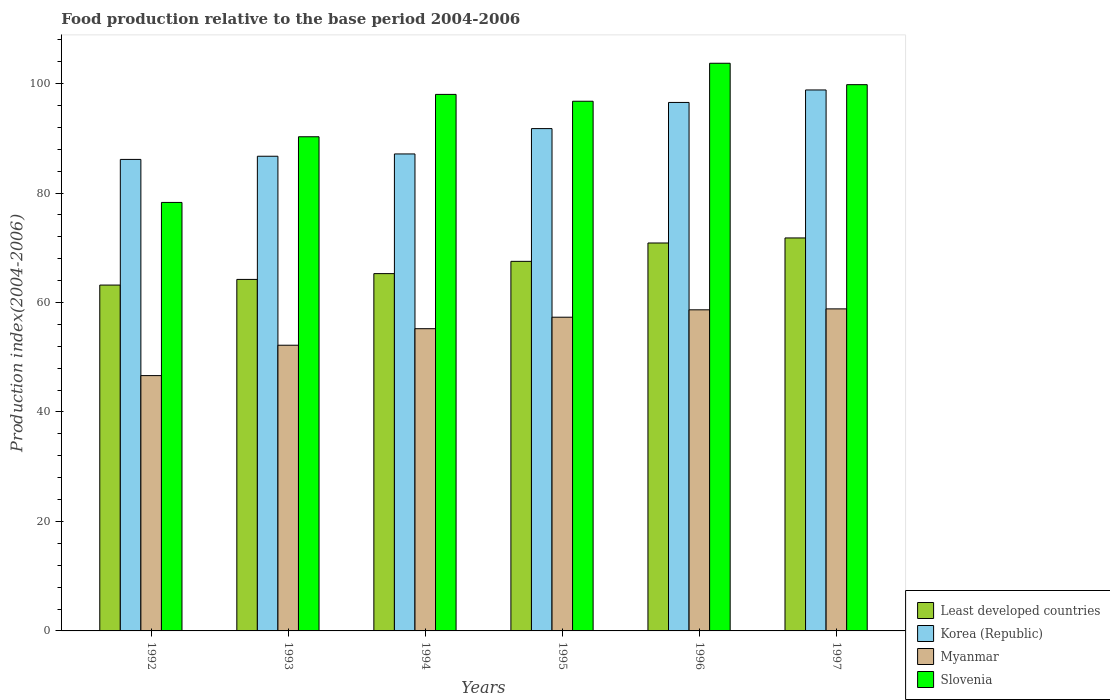How many different coloured bars are there?
Provide a short and direct response. 4. How many groups of bars are there?
Give a very brief answer. 6. How many bars are there on the 6th tick from the left?
Offer a terse response. 4. In how many cases, is the number of bars for a given year not equal to the number of legend labels?
Make the answer very short. 0. What is the food production index in Korea (Republic) in 1997?
Make the answer very short. 98.84. Across all years, what is the maximum food production index in Least developed countries?
Ensure brevity in your answer.  71.8. Across all years, what is the minimum food production index in Myanmar?
Your response must be concise. 46.65. What is the total food production index in Least developed countries in the graph?
Offer a very short reply. 402.91. What is the difference between the food production index in Slovenia in 1994 and that in 1997?
Provide a short and direct response. -1.78. What is the difference between the food production index in Korea (Republic) in 1992 and the food production index in Myanmar in 1995?
Make the answer very short. 28.83. What is the average food production index in Korea (Republic) per year?
Offer a very short reply. 91.2. In the year 1993, what is the difference between the food production index in Slovenia and food production index in Myanmar?
Ensure brevity in your answer.  38.09. In how many years, is the food production index in Slovenia greater than 40?
Provide a short and direct response. 6. What is the ratio of the food production index in Slovenia in 1993 to that in 1995?
Offer a terse response. 0.93. Is the food production index in Myanmar in 1992 less than that in 1994?
Keep it short and to the point. Yes. What is the difference between the highest and the second highest food production index in Slovenia?
Ensure brevity in your answer.  3.91. What is the difference between the highest and the lowest food production index in Korea (Republic)?
Provide a short and direct response. 12.69. In how many years, is the food production index in Myanmar greater than the average food production index in Myanmar taken over all years?
Give a very brief answer. 4. Is the sum of the food production index in Least developed countries in 1992 and 1997 greater than the maximum food production index in Myanmar across all years?
Ensure brevity in your answer.  Yes. What does the 3rd bar from the left in 1997 represents?
Offer a terse response. Myanmar. What does the 2nd bar from the right in 1992 represents?
Your answer should be compact. Myanmar. Is it the case that in every year, the sum of the food production index in Myanmar and food production index in Korea (Republic) is greater than the food production index in Slovenia?
Offer a terse response. Yes. How many years are there in the graph?
Your answer should be compact. 6. Where does the legend appear in the graph?
Offer a terse response. Bottom right. How many legend labels are there?
Keep it short and to the point. 4. How are the legend labels stacked?
Your response must be concise. Vertical. What is the title of the graph?
Your response must be concise. Food production relative to the base period 2004-2006. Does "Cayman Islands" appear as one of the legend labels in the graph?
Your answer should be compact. No. What is the label or title of the X-axis?
Your response must be concise. Years. What is the label or title of the Y-axis?
Offer a very short reply. Production index(2004-2006). What is the Production index(2004-2006) of Least developed countries in 1992?
Your answer should be very brief. 63.19. What is the Production index(2004-2006) in Korea (Republic) in 1992?
Keep it short and to the point. 86.15. What is the Production index(2004-2006) in Myanmar in 1992?
Offer a very short reply. 46.65. What is the Production index(2004-2006) in Slovenia in 1992?
Your answer should be compact. 78.29. What is the Production index(2004-2006) in Least developed countries in 1993?
Keep it short and to the point. 64.22. What is the Production index(2004-2006) of Korea (Republic) in 1993?
Give a very brief answer. 86.73. What is the Production index(2004-2006) in Myanmar in 1993?
Provide a short and direct response. 52.2. What is the Production index(2004-2006) of Slovenia in 1993?
Offer a terse response. 90.29. What is the Production index(2004-2006) in Least developed countries in 1994?
Ensure brevity in your answer.  65.28. What is the Production index(2004-2006) in Korea (Republic) in 1994?
Ensure brevity in your answer.  87.15. What is the Production index(2004-2006) in Myanmar in 1994?
Offer a terse response. 55.22. What is the Production index(2004-2006) in Slovenia in 1994?
Give a very brief answer. 98.03. What is the Production index(2004-2006) of Least developed countries in 1995?
Your response must be concise. 67.53. What is the Production index(2004-2006) of Korea (Republic) in 1995?
Keep it short and to the point. 91.78. What is the Production index(2004-2006) of Myanmar in 1995?
Keep it short and to the point. 57.32. What is the Production index(2004-2006) of Slovenia in 1995?
Give a very brief answer. 96.78. What is the Production index(2004-2006) in Least developed countries in 1996?
Keep it short and to the point. 70.88. What is the Production index(2004-2006) of Korea (Republic) in 1996?
Make the answer very short. 96.56. What is the Production index(2004-2006) of Myanmar in 1996?
Give a very brief answer. 58.67. What is the Production index(2004-2006) of Slovenia in 1996?
Ensure brevity in your answer.  103.72. What is the Production index(2004-2006) in Least developed countries in 1997?
Your answer should be very brief. 71.8. What is the Production index(2004-2006) of Korea (Republic) in 1997?
Keep it short and to the point. 98.84. What is the Production index(2004-2006) of Myanmar in 1997?
Your response must be concise. 58.84. What is the Production index(2004-2006) in Slovenia in 1997?
Your response must be concise. 99.81. Across all years, what is the maximum Production index(2004-2006) of Least developed countries?
Make the answer very short. 71.8. Across all years, what is the maximum Production index(2004-2006) in Korea (Republic)?
Your answer should be compact. 98.84. Across all years, what is the maximum Production index(2004-2006) in Myanmar?
Provide a short and direct response. 58.84. Across all years, what is the maximum Production index(2004-2006) in Slovenia?
Provide a succinct answer. 103.72. Across all years, what is the minimum Production index(2004-2006) in Least developed countries?
Make the answer very short. 63.19. Across all years, what is the minimum Production index(2004-2006) in Korea (Republic)?
Ensure brevity in your answer.  86.15. Across all years, what is the minimum Production index(2004-2006) of Myanmar?
Your answer should be very brief. 46.65. Across all years, what is the minimum Production index(2004-2006) in Slovenia?
Make the answer very short. 78.29. What is the total Production index(2004-2006) of Least developed countries in the graph?
Your response must be concise. 402.91. What is the total Production index(2004-2006) in Korea (Republic) in the graph?
Provide a short and direct response. 547.21. What is the total Production index(2004-2006) in Myanmar in the graph?
Offer a very short reply. 328.9. What is the total Production index(2004-2006) in Slovenia in the graph?
Your answer should be compact. 566.92. What is the difference between the Production index(2004-2006) of Least developed countries in 1992 and that in 1993?
Your answer should be compact. -1.03. What is the difference between the Production index(2004-2006) of Korea (Republic) in 1992 and that in 1993?
Keep it short and to the point. -0.58. What is the difference between the Production index(2004-2006) of Myanmar in 1992 and that in 1993?
Provide a short and direct response. -5.55. What is the difference between the Production index(2004-2006) in Slovenia in 1992 and that in 1993?
Your answer should be compact. -12. What is the difference between the Production index(2004-2006) of Least developed countries in 1992 and that in 1994?
Ensure brevity in your answer.  -2.09. What is the difference between the Production index(2004-2006) in Korea (Republic) in 1992 and that in 1994?
Keep it short and to the point. -1. What is the difference between the Production index(2004-2006) of Myanmar in 1992 and that in 1994?
Ensure brevity in your answer.  -8.57. What is the difference between the Production index(2004-2006) in Slovenia in 1992 and that in 1994?
Ensure brevity in your answer.  -19.74. What is the difference between the Production index(2004-2006) in Least developed countries in 1992 and that in 1995?
Offer a very short reply. -4.33. What is the difference between the Production index(2004-2006) in Korea (Republic) in 1992 and that in 1995?
Keep it short and to the point. -5.63. What is the difference between the Production index(2004-2006) in Myanmar in 1992 and that in 1995?
Give a very brief answer. -10.67. What is the difference between the Production index(2004-2006) in Slovenia in 1992 and that in 1995?
Keep it short and to the point. -18.49. What is the difference between the Production index(2004-2006) of Least developed countries in 1992 and that in 1996?
Offer a very short reply. -7.69. What is the difference between the Production index(2004-2006) of Korea (Republic) in 1992 and that in 1996?
Give a very brief answer. -10.41. What is the difference between the Production index(2004-2006) of Myanmar in 1992 and that in 1996?
Your response must be concise. -12.02. What is the difference between the Production index(2004-2006) of Slovenia in 1992 and that in 1996?
Offer a very short reply. -25.43. What is the difference between the Production index(2004-2006) of Least developed countries in 1992 and that in 1997?
Offer a terse response. -8.61. What is the difference between the Production index(2004-2006) of Korea (Republic) in 1992 and that in 1997?
Give a very brief answer. -12.69. What is the difference between the Production index(2004-2006) in Myanmar in 1992 and that in 1997?
Give a very brief answer. -12.19. What is the difference between the Production index(2004-2006) of Slovenia in 1992 and that in 1997?
Give a very brief answer. -21.52. What is the difference between the Production index(2004-2006) in Least developed countries in 1993 and that in 1994?
Ensure brevity in your answer.  -1.06. What is the difference between the Production index(2004-2006) in Korea (Republic) in 1993 and that in 1994?
Keep it short and to the point. -0.42. What is the difference between the Production index(2004-2006) in Myanmar in 1993 and that in 1994?
Ensure brevity in your answer.  -3.02. What is the difference between the Production index(2004-2006) in Slovenia in 1993 and that in 1994?
Make the answer very short. -7.74. What is the difference between the Production index(2004-2006) in Least developed countries in 1993 and that in 1995?
Your answer should be compact. -3.3. What is the difference between the Production index(2004-2006) of Korea (Republic) in 1993 and that in 1995?
Give a very brief answer. -5.05. What is the difference between the Production index(2004-2006) in Myanmar in 1993 and that in 1995?
Your response must be concise. -5.12. What is the difference between the Production index(2004-2006) of Slovenia in 1993 and that in 1995?
Your answer should be compact. -6.49. What is the difference between the Production index(2004-2006) of Least developed countries in 1993 and that in 1996?
Provide a short and direct response. -6.66. What is the difference between the Production index(2004-2006) in Korea (Republic) in 1993 and that in 1996?
Provide a succinct answer. -9.83. What is the difference between the Production index(2004-2006) of Myanmar in 1993 and that in 1996?
Ensure brevity in your answer.  -6.47. What is the difference between the Production index(2004-2006) of Slovenia in 1993 and that in 1996?
Make the answer very short. -13.43. What is the difference between the Production index(2004-2006) of Least developed countries in 1993 and that in 1997?
Your response must be concise. -7.58. What is the difference between the Production index(2004-2006) of Korea (Republic) in 1993 and that in 1997?
Your response must be concise. -12.11. What is the difference between the Production index(2004-2006) of Myanmar in 1993 and that in 1997?
Make the answer very short. -6.64. What is the difference between the Production index(2004-2006) of Slovenia in 1993 and that in 1997?
Provide a short and direct response. -9.52. What is the difference between the Production index(2004-2006) in Least developed countries in 1994 and that in 1995?
Your response must be concise. -2.24. What is the difference between the Production index(2004-2006) of Korea (Republic) in 1994 and that in 1995?
Ensure brevity in your answer.  -4.63. What is the difference between the Production index(2004-2006) in Least developed countries in 1994 and that in 1996?
Your answer should be compact. -5.6. What is the difference between the Production index(2004-2006) in Korea (Republic) in 1994 and that in 1996?
Ensure brevity in your answer.  -9.41. What is the difference between the Production index(2004-2006) of Myanmar in 1994 and that in 1996?
Offer a very short reply. -3.45. What is the difference between the Production index(2004-2006) in Slovenia in 1994 and that in 1996?
Your answer should be compact. -5.69. What is the difference between the Production index(2004-2006) in Least developed countries in 1994 and that in 1997?
Keep it short and to the point. -6.52. What is the difference between the Production index(2004-2006) of Korea (Republic) in 1994 and that in 1997?
Your answer should be compact. -11.69. What is the difference between the Production index(2004-2006) in Myanmar in 1994 and that in 1997?
Your answer should be very brief. -3.62. What is the difference between the Production index(2004-2006) of Slovenia in 1994 and that in 1997?
Offer a very short reply. -1.78. What is the difference between the Production index(2004-2006) in Least developed countries in 1995 and that in 1996?
Provide a succinct answer. -3.36. What is the difference between the Production index(2004-2006) of Korea (Republic) in 1995 and that in 1996?
Provide a succinct answer. -4.78. What is the difference between the Production index(2004-2006) of Myanmar in 1995 and that in 1996?
Provide a succinct answer. -1.35. What is the difference between the Production index(2004-2006) in Slovenia in 1995 and that in 1996?
Your answer should be very brief. -6.94. What is the difference between the Production index(2004-2006) in Least developed countries in 1995 and that in 1997?
Provide a short and direct response. -4.28. What is the difference between the Production index(2004-2006) of Korea (Republic) in 1995 and that in 1997?
Keep it short and to the point. -7.06. What is the difference between the Production index(2004-2006) of Myanmar in 1995 and that in 1997?
Ensure brevity in your answer.  -1.52. What is the difference between the Production index(2004-2006) in Slovenia in 1995 and that in 1997?
Offer a very short reply. -3.03. What is the difference between the Production index(2004-2006) in Least developed countries in 1996 and that in 1997?
Offer a terse response. -0.92. What is the difference between the Production index(2004-2006) of Korea (Republic) in 1996 and that in 1997?
Provide a succinct answer. -2.28. What is the difference between the Production index(2004-2006) of Myanmar in 1996 and that in 1997?
Your answer should be compact. -0.17. What is the difference between the Production index(2004-2006) in Slovenia in 1996 and that in 1997?
Provide a succinct answer. 3.91. What is the difference between the Production index(2004-2006) in Least developed countries in 1992 and the Production index(2004-2006) in Korea (Republic) in 1993?
Make the answer very short. -23.54. What is the difference between the Production index(2004-2006) in Least developed countries in 1992 and the Production index(2004-2006) in Myanmar in 1993?
Ensure brevity in your answer.  10.99. What is the difference between the Production index(2004-2006) of Least developed countries in 1992 and the Production index(2004-2006) of Slovenia in 1993?
Your response must be concise. -27.1. What is the difference between the Production index(2004-2006) of Korea (Republic) in 1992 and the Production index(2004-2006) of Myanmar in 1993?
Offer a very short reply. 33.95. What is the difference between the Production index(2004-2006) of Korea (Republic) in 1992 and the Production index(2004-2006) of Slovenia in 1993?
Make the answer very short. -4.14. What is the difference between the Production index(2004-2006) in Myanmar in 1992 and the Production index(2004-2006) in Slovenia in 1993?
Provide a succinct answer. -43.64. What is the difference between the Production index(2004-2006) in Least developed countries in 1992 and the Production index(2004-2006) in Korea (Republic) in 1994?
Your answer should be compact. -23.96. What is the difference between the Production index(2004-2006) in Least developed countries in 1992 and the Production index(2004-2006) in Myanmar in 1994?
Ensure brevity in your answer.  7.97. What is the difference between the Production index(2004-2006) in Least developed countries in 1992 and the Production index(2004-2006) in Slovenia in 1994?
Offer a terse response. -34.84. What is the difference between the Production index(2004-2006) of Korea (Republic) in 1992 and the Production index(2004-2006) of Myanmar in 1994?
Ensure brevity in your answer.  30.93. What is the difference between the Production index(2004-2006) in Korea (Republic) in 1992 and the Production index(2004-2006) in Slovenia in 1994?
Offer a terse response. -11.88. What is the difference between the Production index(2004-2006) of Myanmar in 1992 and the Production index(2004-2006) of Slovenia in 1994?
Your answer should be compact. -51.38. What is the difference between the Production index(2004-2006) of Least developed countries in 1992 and the Production index(2004-2006) of Korea (Republic) in 1995?
Your answer should be very brief. -28.59. What is the difference between the Production index(2004-2006) of Least developed countries in 1992 and the Production index(2004-2006) of Myanmar in 1995?
Keep it short and to the point. 5.87. What is the difference between the Production index(2004-2006) in Least developed countries in 1992 and the Production index(2004-2006) in Slovenia in 1995?
Ensure brevity in your answer.  -33.59. What is the difference between the Production index(2004-2006) of Korea (Republic) in 1992 and the Production index(2004-2006) of Myanmar in 1995?
Your response must be concise. 28.83. What is the difference between the Production index(2004-2006) of Korea (Republic) in 1992 and the Production index(2004-2006) of Slovenia in 1995?
Provide a succinct answer. -10.63. What is the difference between the Production index(2004-2006) of Myanmar in 1992 and the Production index(2004-2006) of Slovenia in 1995?
Offer a very short reply. -50.13. What is the difference between the Production index(2004-2006) in Least developed countries in 1992 and the Production index(2004-2006) in Korea (Republic) in 1996?
Keep it short and to the point. -33.37. What is the difference between the Production index(2004-2006) in Least developed countries in 1992 and the Production index(2004-2006) in Myanmar in 1996?
Keep it short and to the point. 4.52. What is the difference between the Production index(2004-2006) in Least developed countries in 1992 and the Production index(2004-2006) in Slovenia in 1996?
Make the answer very short. -40.53. What is the difference between the Production index(2004-2006) of Korea (Republic) in 1992 and the Production index(2004-2006) of Myanmar in 1996?
Offer a terse response. 27.48. What is the difference between the Production index(2004-2006) of Korea (Republic) in 1992 and the Production index(2004-2006) of Slovenia in 1996?
Your answer should be very brief. -17.57. What is the difference between the Production index(2004-2006) in Myanmar in 1992 and the Production index(2004-2006) in Slovenia in 1996?
Your answer should be compact. -57.07. What is the difference between the Production index(2004-2006) in Least developed countries in 1992 and the Production index(2004-2006) in Korea (Republic) in 1997?
Provide a succinct answer. -35.65. What is the difference between the Production index(2004-2006) of Least developed countries in 1992 and the Production index(2004-2006) of Myanmar in 1997?
Keep it short and to the point. 4.35. What is the difference between the Production index(2004-2006) in Least developed countries in 1992 and the Production index(2004-2006) in Slovenia in 1997?
Give a very brief answer. -36.62. What is the difference between the Production index(2004-2006) of Korea (Republic) in 1992 and the Production index(2004-2006) of Myanmar in 1997?
Your answer should be compact. 27.31. What is the difference between the Production index(2004-2006) in Korea (Republic) in 1992 and the Production index(2004-2006) in Slovenia in 1997?
Ensure brevity in your answer.  -13.66. What is the difference between the Production index(2004-2006) of Myanmar in 1992 and the Production index(2004-2006) of Slovenia in 1997?
Offer a terse response. -53.16. What is the difference between the Production index(2004-2006) of Least developed countries in 1993 and the Production index(2004-2006) of Korea (Republic) in 1994?
Your response must be concise. -22.93. What is the difference between the Production index(2004-2006) in Least developed countries in 1993 and the Production index(2004-2006) in Myanmar in 1994?
Make the answer very short. 9.01. What is the difference between the Production index(2004-2006) of Least developed countries in 1993 and the Production index(2004-2006) of Slovenia in 1994?
Your answer should be very brief. -33.8. What is the difference between the Production index(2004-2006) of Korea (Republic) in 1993 and the Production index(2004-2006) of Myanmar in 1994?
Ensure brevity in your answer.  31.51. What is the difference between the Production index(2004-2006) in Korea (Republic) in 1993 and the Production index(2004-2006) in Slovenia in 1994?
Offer a terse response. -11.3. What is the difference between the Production index(2004-2006) in Myanmar in 1993 and the Production index(2004-2006) in Slovenia in 1994?
Offer a terse response. -45.83. What is the difference between the Production index(2004-2006) in Least developed countries in 1993 and the Production index(2004-2006) in Korea (Republic) in 1995?
Make the answer very short. -27.55. What is the difference between the Production index(2004-2006) of Least developed countries in 1993 and the Production index(2004-2006) of Myanmar in 1995?
Provide a short and direct response. 6.91. What is the difference between the Production index(2004-2006) of Least developed countries in 1993 and the Production index(2004-2006) of Slovenia in 1995?
Your answer should be compact. -32.55. What is the difference between the Production index(2004-2006) in Korea (Republic) in 1993 and the Production index(2004-2006) in Myanmar in 1995?
Make the answer very short. 29.41. What is the difference between the Production index(2004-2006) in Korea (Republic) in 1993 and the Production index(2004-2006) in Slovenia in 1995?
Provide a succinct answer. -10.05. What is the difference between the Production index(2004-2006) in Myanmar in 1993 and the Production index(2004-2006) in Slovenia in 1995?
Make the answer very short. -44.58. What is the difference between the Production index(2004-2006) in Least developed countries in 1993 and the Production index(2004-2006) in Korea (Republic) in 1996?
Offer a terse response. -32.34. What is the difference between the Production index(2004-2006) in Least developed countries in 1993 and the Production index(2004-2006) in Myanmar in 1996?
Offer a very short reply. 5.55. What is the difference between the Production index(2004-2006) of Least developed countries in 1993 and the Production index(2004-2006) of Slovenia in 1996?
Ensure brevity in your answer.  -39.49. What is the difference between the Production index(2004-2006) of Korea (Republic) in 1993 and the Production index(2004-2006) of Myanmar in 1996?
Your answer should be compact. 28.06. What is the difference between the Production index(2004-2006) in Korea (Republic) in 1993 and the Production index(2004-2006) in Slovenia in 1996?
Give a very brief answer. -16.99. What is the difference between the Production index(2004-2006) of Myanmar in 1993 and the Production index(2004-2006) of Slovenia in 1996?
Your answer should be very brief. -51.52. What is the difference between the Production index(2004-2006) of Least developed countries in 1993 and the Production index(2004-2006) of Korea (Republic) in 1997?
Ensure brevity in your answer.  -34.62. What is the difference between the Production index(2004-2006) in Least developed countries in 1993 and the Production index(2004-2006) in Myanmar in 1997?
Offer a very short reply. 5.38. What is the difference between the Production index(2004-2006) in Least developed countries in 1993 and the Production index(2004-2006) in Slovenia in 1997?
Your response must be concise. -35.59. What is the difference between the Production index(2004-2006) in Korea (Republic) in 1993 and the Production index(2004-2006) in Myanmar in 1997?
Provide a short and direct response. 27.89. What is the difference between the Production index(2004-2006) of Korea (Republic) in 1993 and the Production index(2004-2006) of Slovenia in 1997?
Your answer should be compact. -13.08. What is the difference between the Production index(2004-2006) in Myanmar in 1993 and the Production index(2004-2006) in Slovenia in 1997?
Your answer should be very brief. -47.61. What is the difference between the Production index(2004-2006) of Least developed countries in 1994 and the Production index(2004-2006) of Korea (Republic) in 1995?
Your response must be concise. -26.5. What is the difference between the Production index(2004-2006) of Least developed countries in 1994 and the Production index(2004-2006) of Myanmar in 1995?
Your answer should be very brief. 7.96. What is the difference between the Production index(2004-2006) in Least developed countries in 1994 and the Production index(2004-2006) in Slovenia in 1995?
Your response must be concise. -31.5. What is the difference between the Production index(2004-2006) in Korea (Republic) in 1994 and the Production index(2004-2006) in Myanmar in 1995?
Keep it short and to the point. 29.83. What is the difference between the Production index(2004-2006) in Korea (Republic) in 1994 and the Production index(2004-2006) in Slovenia in 1995?
Ensure brevity in your answer.  -9.63. What is the difference between the Production index(2004-2006) of Myanmar in 1994 and the Production index(2004-2006) of Slovenia in 1995?
Your response must be concise. -41.56. What is the difference between the Production index(2004-2006) of Least developed countries in 1994 and the Production index(2004-2006) of Korea (Republic) in 1996?
Offer a terse response. -31.28. What is the difference between the Production index(2004-2006) of Least developed countries in 1994 and the Production index(2004-2006) of Myanmar in 1996?
Provide a short and direct response. 6.61. What is the difference between the Production index(2004-2006) in Least developed countries in 1994 and the Production index(2004-2006) in Slovenia in 1996?
Offer a very short reply. -38.44. What is the difference between the Production index(2004-2006) of Korea (Republic) in 1994 and the Production index(2004-2006) of Myanmar in 1996?
Keep it short and to the point. 28.48. What is the difference between the Production index(2004-2006) of Korea (Republic) in 1994 and the Production index(2004-2006) of Slovenia in 1996?
Your response must be concise. -16.57. What is the difference between the Production index(2004-2006) in Myanmar in 1994 and the Production index(2004-2006) in Slovenia in 1996?
Offer a very short reply. -48.5. What is the difference between the Production index(2004-2006) in Least developed countries in 1994 and the Production index(2004-2006) in Korea (Republic) in 1997?
Keep it short and to the point. -33.56. What is the difference between the Production index(2004-2006) in Least developed countries in 1994 and the Production index(2004-2006) in Myanmar in 1997?
Your answer should be compact. 6.44. What is the difference between the Production index(2004-2006) in Least developed countries in 1994 and the Production index(2004-2006) in Slovenia in 1997?
Your answer should be very brief. -34.53. What is the difference between the Production index(2004-2006) of Korea (Republic) in 1994 and the Production index(2004-2006) of Myanmar in 1997?
Your response must be concise. 28.31. What is the difference between the Production index(2004-2006) of Korea (Republic) in 1994 and the Production index(2004-2006) of Slovenia in 1997?
Ensure brevity in your answer.  -12.66. What is the difference between the Production index(2004-2006) in Myanmar in 1994 and the Production index(2004-2006) in Slovenia in 1997?
Your response must be concise. -44.59. What is the difference between the Production index(2004-2006) in Least developed countries in 1995 and the Production index(2004-2006) in Korea (Republic) in 1996?
Make the answer very short. -29.03. What is the difference between the Production index(2004-2006) in Least developed countries in 1995 and the Production index(2004-2006) in Myanmar in 1996?
Provide a short and direct response. 8.86. What is the difference between the Production index(2004-2006) in Least developed countries in 1995 and the Production index(2004-2006) in Slovenia in 1996?
Offer a terse response. -36.19. What is the difference between the Production index(2004-2006) in Korea (Republic) in 1995 and the Production index(2004-2006) in Myanmar in 1996?
Give a very brief answer. 33.11. What is the difference between the Production index(2004-2006) of Korea (Republic) in 1995 and the Production index(2004-2006) of Slovenia in 1996?
Offer a very short reply. -11.94. What is the difference between the Production index(2004-2006) in Myanmar in 1995 and the Production index(2004-2006) in Slovenia in 1996?
Keep it short and to the point. -46.4. What is the difference between the Production index(2004-2006) of Least developed countries in 1995 and the Production index(2004-2006) of Korea (Republic) in 1997?
Offer a terse response. -31.31. What is the difference between the Production index(2004-2006) of Least developed countries in 1995 and the Production index(2004-2006) of Myanmar in 1997?
Give a very brief answer. 8.69. What is the difference between the Production index(2004-2006) of Least developed countries in 1995 and the Production index(2004-2006) of Slovenia in 1997?
Keep it short and to the point. -32.28. What is the difference between the Production index(2004-2006) of Korea (Republic) in 1995 and the Production index(2004-2006) of Myanmar in 1997?
Ensure brevity in your answer.  32.94. What is the difference between the Production index(2004-2006) in Korea (Republic) in 1995 and the Production index(2004-2006) in Slovenia in 1997?
Keep it short and to the point. -8.03. What is the difference between the Production index(2004-2006) of Myanmar in 1995 and the Production index(2004-2006) of Slovenia in 1997?
Your answer should be very brief. -42.49. What is the difference between the Production index(2004-2006) in Least developed countries in 1996 and the Production index(2004-2006) in Korea (Republic) in 1997?
Keep it short and to the point. -27.96. What is the difference between the Production index(2004-2006) in Least developed countries in 1996 and the Production index(2004-2006) in Myanmar in 1997?
Provide a succinct answer. 12.04. What is the difference between the Production index(2004-2006) in Least developed countries in 1996 and the Production index(2004-2006) in Slovenia in 1997?
Your answer should be very brief. -28.93. What is the difference between the Production index(2004-2006) of Korea (Republic) in 1996 and the Production index(2004-2006) of Myanmar in 1997?
Provide a succinct answer. 37.72. What is the difference between the Production index(2004-2006) of Korea (Republic) in 1996 and the Production index(2004-2006) of Slovenia in 1997?
Make the answer very short. -3.25. What is the difference between the Production index(2004-2006) in Myanmar in 1996 and the Production index(2004-2006) in Slovenia in 1997?
Offer a very short reply. -41.14. What is the average Production index(2004-2006) of Least developed countries per year?
Your answer should be compact. 67.15. What is the average Production index(2004-2006) in Korea (Republic) per year?
Make the answer very short. 91.2. What is the average Production index(2004-2006) of Myanmar per year?
Ensure brevity in your answer.  54.82. What is the average Production index(2004-2006) in Slovenia per year?
Ensure brevity in your answer.  94.49. In the year 1992, what is the difference between the Production index(2004-2006) in Least developed countries and Production index(2004-2006) in Korea (Republic)?
Ensure brevity in your answer.  -22.96. In the year 1992, what is the difference between the Production index(2004-2006) in Least developed countries and Production index(2004-2006) in Myanmar?
Make the answer very short. 16.54. In the year 1992, what is the difference between the Production index(2004-2006) of Least developed countries and Production index(2004-2006) of Slovenia?
Provide a succinct answer. -15.1. In the year 1992, what is the difference between the Production index(2004-2006) of Korea (Republic) and Production index(2004-2006) of Myanmar?
Your response must be concise. 39.5. In the year 1992, what is the difference between the Production index(2004-2006) of Korea (Republic) and Production index(2004-2006) of Slovenia?
Your answer should be compact. 7.86. In the year 1992, what is the difference between the Production index(2004-2006) of Myanmar and Production index(2004-2006) of Slovenia?
Your answer should be compact. -31.64. In the year 1993, what is the difference between the Production index(2004-2006) in Least developed countries and Production index(2004-2006) in Korea (Republic)?
Provide a succinct answer. -22.5. In the year 1993, what is the difference between the Production index(2004-2006) of Least developed countries and Production index(2004-2006) of Myanmar?
Ensure brevity in your answer.  12.03. In the year 1993, what is the difference between the Production index(2004-2006) of Least developed countries and Production index(2004-2006) of Slovenia?
Provide a short and direct response. -26.07. In the year 1993, what is the difference between the Production index(2004-2006) in Korea (Republic) and Production index(2004-2006) in Myanmar?
Offer a terse response. 34.53. In the year 1993, what is the difference between the Production index(2004-2006) of Korea (Republic) and Production index(2004-2006) of Slovenia?
Keep it short and to the point. -3.56. In the year 1993, what is the difference between the Production index(2004-2006) in Myanmar and Production index(2004-2006) in Slovenia?
Offer a terse response. -38.09. In the year 1994, what is the difference between the Production index(2004-2006) of Least developed countries and Production index(2004-2006) of Korea (Republic)?
Give a very brief answer. -21.87. In the year 1994, what is the difference between the Production index(2004-2006) in Least developed countries and Production index(2004-2006) in Myanmar?
Make the answer very short. 10.06. In the year 1994, what is the difference between the Production index(2004-2006) in Least developed countries and Production index(2004-2006) in Slovenia?
Offer a terse response. -32.75. In the year 1994, what is the difference between the Production index(2004-2006) of Korea (Republic) and Production index(2004-2006) of Myanmar?
Ensure brevity in your answer.  31.93. In the year 1994, what is the difference between the Production index(2004-2006) in Korea (Republic) and Production index(2004-2006) in Slovenia?
Your answer should be very brief. -10.88. In the year 1994, what is the difference between the Production index(2004-2006) of Myanmar and Production index(2004-2006) of Slovenia?
Your answer should be compact. -42.81. In the year 1995, what is the difference between the Production index(2004-2006) of Least developed countries and Production index(2004-2006) of Korea (Republic)?
Give a very brief answer. -24.25. In the year 1995, what is the difference between the Production index(2004-2006) of Least developed countries and Production index(2004-2006) of Myanmar?
Provide a short and direct response. 10.21. In the year 1995, what is the difference between the Production index(2004-2006) of Least developed countries and Production index(2004-2006) of Slovenia?
Your response must be concise. -29.25. In the year 1995, what is the difference between the Production index(2004-2006) of Korea (Republic) and Production index(2004-2006) of Myanmar?
Your answer should be very brief. 34.46. In the year 1995, what is the difference between the Production index(2004-2006) of Korea (Republic) and Production index(2004-2006) of Slovenia?
Your response must be concise. -5. In the year 1995, what is the difference between the Production index(2004-2006) in Myanmar and Production index(2004-2006) in Slovenia?
Offer a very short reply. -39.46. In the year 1996, what is the difference between the Production index(2004-2006) in Least developed countries and Production index(2004-2006) in Korea (Republic)?
Your answer should be very brief. -25.68. In the year 1996, what is the difference between the Production index(2004-2006) of Least developed countries and Production index(2004-2006) of Myanmar?
Ensure brevity in your answer.  12.21. In the year 1996, what is the difference between the Production index(2004-2006) of Least developed countries and Production index(2004-2006) of Slovenia?
Provide a succinct answer. -32.84. In the year 1996, what is the difference between the Production index(2004-2006) of Korea (Republic) and Production index(2004-2006) of Myanmar?
Keep it short and to the point. 37.89. In the year 1996, what is the difference between the Production index(2004-2006) in Korea (Republic) and Production index(2004-2006) in Slovenia?
Give a very brief answer. -7.16. In the year 1996, what is the difference between the Production index(2004-2006) in Myanmar and Production index(2004-2006) in Slovenia?
Your answer should be compact. -45.05. In the year 1997, what is the difference between the Production index(2004-2006) in Least developed countries and Production index(2004-2006) in Korea (Republic)?
Provide a succinct answer. -27.04. In the year 1997, what is the difference between the Production index(2004-2006) of Least developed countries and Production index(2004-2006) of Myanmar?
Offer a terse response. 12.96. In the year 1997, what is the difference between the Production index(2004-2006) of Least developed countries and Production index(2004-2006) of Slovenia?
Offer a terse response. -28.01. In the year 1997, what is the difference between the Production index(2004-2006) of Korea (Republic) and Production index(2004-2006) of Slovenia?
Your answer should be very brief. -0.97. In the year 1997, what is the difference between the Production index(2004-2006) in Myanmar and Production index(2004-2006) in Slovenia?
Ensure brevity in your answer.  -40.97. What is the ratio of the Production index(2004-2006) in Least developed countries in 1992 to that in 1993?
Provide a succinct answer. 0.98. What is the ratio of the Production index(2004-2006) in Korea (Republic) in 1992 to that in 1993?
Give a very brief answer. 0.99. What is the ratio of the Production index(2004-2006) in Myanmar in 1992 to that in 1993?
Provide a short and direct response. 0.89. What is the ratio of the Production index(2004-2006) of Slovenia in 1992 to that in 1993?
Your answer should be compact. 0.87. What is the ratio of the Production index(2004-2006) of Least developed countries in 1992 to that in 1994?
Provide a succinct answer. 0.97. What is the ratio of the Production index(2004-2006) of Korea (Republic) in 1992 to that in 1994?
Offer a very short reply. 0.99. What is the ratio of the Production index(2004-2006) of Myanmar in 1992 to that in 1994?
Your answer should be compact. 0.84. What is the ratio of the Production index(2004-2006) in Slovenia in 1992 to that in 1994?
Provide a succinct answer. 0.8. What is the ratio of the Production index(2004-2006) in Least developed countries in 1992 to that in 1995?
Your response must be concise. 0.94. What is the ratio of the Production index(2004-2006) in Korea (Republic) in 1992 to that in 1995?
Provide a succinct answer. 0.94. What is the ratio of the Production index(2004-2006) of Myanmar in 1992 to that in 1995?
Make the answer very short. 0.81. What is the ratio of the Production index(2004-2006) in Slovenia in 1992 to that in 1995?
Your response must be concise. 0.81. What is the ratio of the Production index(2004-2006) of Least developed countries in 1992 to that in 1996?
Your answer should be compact. 0.89. What is the ratio of the Production index(2004-2006) in Korea (Republic) in 1992 to that in 1996?
Give a very brief answer. 0.89. What is the ratio of the Production index(2004-2006) of Myanmar in 1992 to that in 1996?
Provide a succinct answer. 0.8. What is the ratio of the Production index(2004-2006) of Slovenia in 1992 to that in 1996?
Provide a succinct answer. 0.75. What is the ratio of the Production index(2004-2006) in Least developed countries in 1992 to that in 1997?
Your response must be concise. 0.88. What is the ratio of the Production index(2004-2006) in Korea (Republic) in 1992 to that in 1997?
Your response must be concise. 0.87. What is the ratio of the Production index(2004-2006) of Myanmar in 1992 to that in 1997?
Offer a terse response. 0.79. What is the ratio of the Production index(2004-2006) in Slovenia in 1992 to that in 1997?
Keep it short and to the point. 0.78. What is the ratio of the Production index(2004-2006) in Least developed countries in 1993 to that in 1994?
Provide a short and direct response. 0.98. What is the ratio of the Production index(2004-2006) in Myanmar in 1993 to that in 1994?
Provide a short and direct response. 0.95. What is the ratio of the Production index(2004-2006) in Slovenia in 1993 to that in 1994?
Offer a very short reply. 0.92. What is the ratio of the Production index(2004-2006) of Least developed countries in 1993 to that in 1995?
Offer a terse response. 0.95. What is the ratio of the Production index(2004-2006) in Korea (Republic) in 1993 to that in 1995?
Provide a succinct answer. 0.94. What is the ratio of the Production index(2004-2006) in Myanmar in 1993 to that in 1995?
Provide a succinct answer. 0.91. What is the ratio of the Production index(2004-2006) of Slovenia in 1993 to that in 1995?
Your answer should be compact. 0.93. What is the ratio of the Production index(2004-2006) of Least developed countries in 1993 to that in 1996?
Provide a short and direct response. 0.91. What is the ratio of the Production index(2004-2006) in Korea (Republic) in 1993 to that in 1996?
Make the answer very short. 0.9. What is the ratio of the Production index(2004-2006) in Myanmar in 1993 to that in 1996?
Provide a short and direct response. 0.89. What is the ratio of the Production index(2004-2006) in Slovenia in 1993 to that in 1996?
Your response must be concise. 0.87. What is the ratio of the Production index(2004-2006) of Least developed countries in 1993 to that in 1997?
Offer a terse response. 0.89. What is the ratio of the Production index(2004-2006) of Korea (Republic) in 1993 to that in 1997?
Your response must be concise. 0.88. What is the ratio of the Production index(2004-2006) in Myanmar in 1993 to that in 1997?
Give a very brief answer. 0.89. What is the ratio of the Production index(2004-2006) in Slovenia in 1993 to that in 1997?
Give a very brief answer. 0.9. What is the ratio of the Production index(2004-2006) of Least developed countries in 1994 to that in 1995?
Offer a terse response. 0.97. What is the ratio of the Production index(2004-2006) in Korea (Republic) in 1994 to that in 1995?
Make the answer very short. 0.95. What is the ratio of the Production index(2004-2006) of Myanmar in 1994 to that in 1995?
Make the answer very short. 0.96. What is the ratio of the Production index(2004-2006) in Slovenia in 1994 to that in 1995?
Give a very brief answer. 1.01. What is the ratio of the Production index(2004-2006) of Least developed countries in 1994 to that in 1996?
Your answer should be compact. 0.92. What is the ratio of the Production index(2004-2006) in Korea (Republic) in 1994 to that in 1996?
Provide a short and direct response. 0.9. What is the ratio of the Production index(2004-2006) in Myanmar in 1994 to that in 1996?
Provide a succinct answer. 0.94. What is the ratio of the Production index(2004-2006) in Slovenia in 1994 to that in 1996?
Offer a terse response. 0.95. What is the ratio of the Production index(2004-2006) of Least developed countries in 1994 to that in 1997?
Provide a succinct answer. 0.91. What is the ratio of the Production index(2004-2006) of Korea (Republic) in 1994 to that in 1997?
Your response must be concise. 0.88. What is the ratio of the Production index(2004-2006) of Myanmar in 1994 to that in 1997?
Ensure brevity in your answer.  0.94. What is the ratio of the Production index(2004-2006) of Slovenia in 1994 to that in 1997?
Offer a terse response. 0.98. What is the ratio of the Production index(2004-2006) of Least developed countries in 1995 to that in 1996?
Offer a very short reply. 0.95. What is the ratio of the Production index(2004-2006) of Korea (Republic) in 1995 to that in 1996?
Give a very brief answer. 0.95. What is the ratio of the Production index(2004-2006) in Slovenia in 1995 to that in 1996?
Your answer should be compact. 0.93. What is the ratio of the Production index(2004-2006) of Least developed countries in 1995 to that in 1997?
Give a very brief answer. 0.94. What is the ratio of the Production index(2004-2006) in Myanmar in 1995 to that in 1997?
Provide a succinct answer. 0.97. What is the ratio of the Production index(2004-2006) of Slovenia in 1995 to that in 1997?
Provide a short and direct response. 0.97. What is the ratio of the Production index(2004-2006) in Least developed countries in 1996 to that in 1997?
Provide a succinct answer. 0.99. What is the ratio of the Production index(2004-2006) in Korea (Republic) in 1996 to that in 1997?
Your answer should be very brief. 0.98. What is the ratio of the Production index(2004-2006) of Slovenia in 1996 to that in 1997?
Your answer should be very brief. 1.04. What is the difference between the highest and the second highest Production index(2004-2006) of Least developed countries?
Make the answer very short. 0.92. What is the difference between the highest and the second highest Production index(2004-2006) in Korea (Republic)?
Give a very brief answer. 2.28. What is the difference between the highest and the second highest Production index(2004-2006) in Myanmar?
Make the answer very short. 0.17. What is the difference between the highest and the second highest Production index(2004-2006) in Slovenia?
Provide a short and direct response. 3.91. What is the difference between the highest and the lowest Production index(2004-2006) in Least developed countries?
Offer a very short reply. 8.61. What is the difference between the highest and the lowest Production index(2004-2006) in Korea (Republic)?
Your answer should be compact. 12.69. What is the difference between the highest and the lowest Production index(2004-2006) of Myanmar?
Make the answer very short. 12.19. What is the difference between the highest and the lowest Production index(2004-2006) in Slovenia?
Your response must be concise. 25.43. 